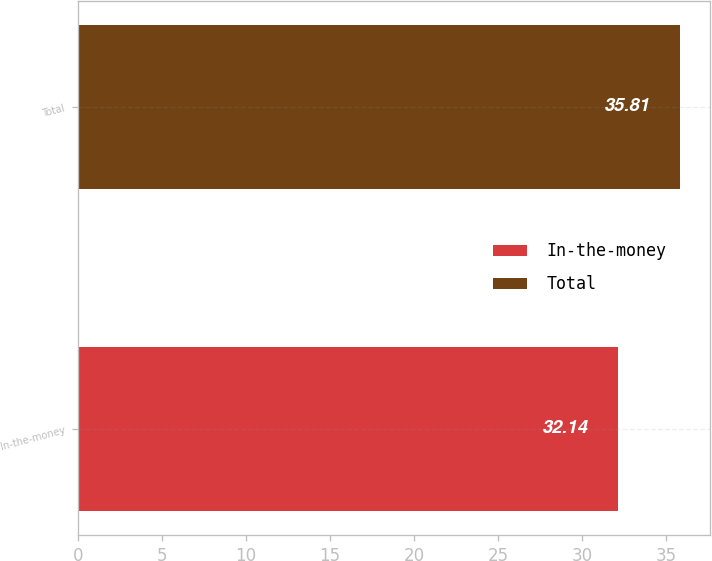<chart> <loc_0><loc_0><loc_500><loc_500><bar_chart><fcel>In-the-money<fcel>Total<nl><fcel>32.14<fcel>35.81<nl></chart> 